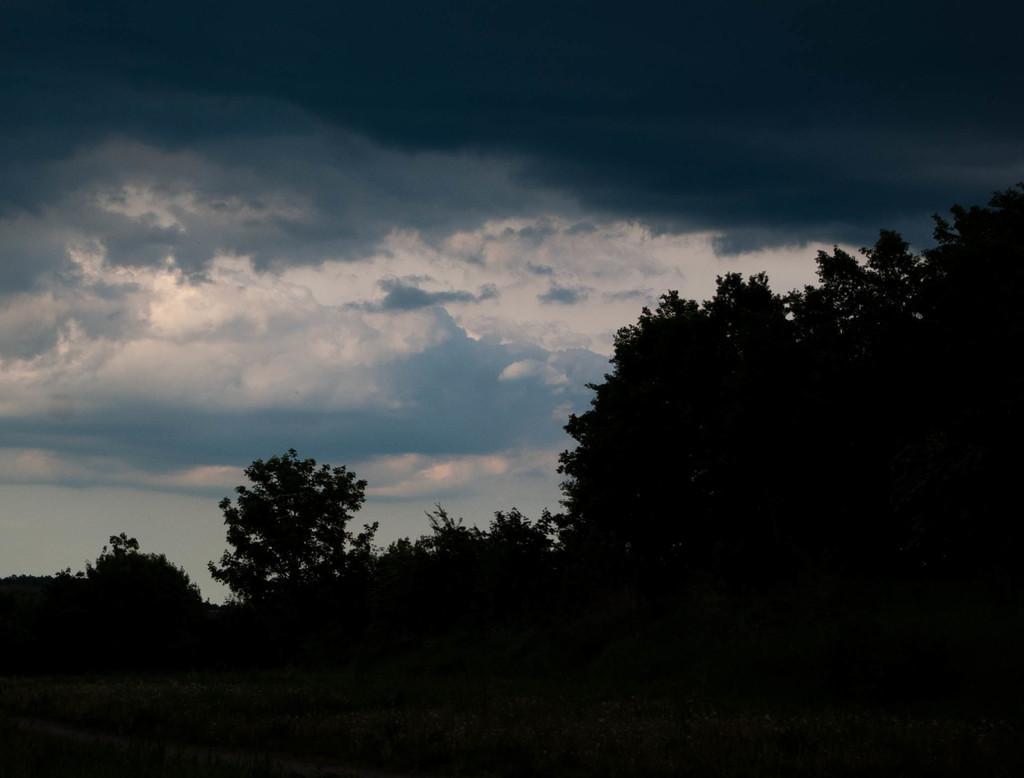In one or two sentences, can you explain what this image depicts? In this image, I can see the clouds in the sky. There are the trees with branches and leaves. 